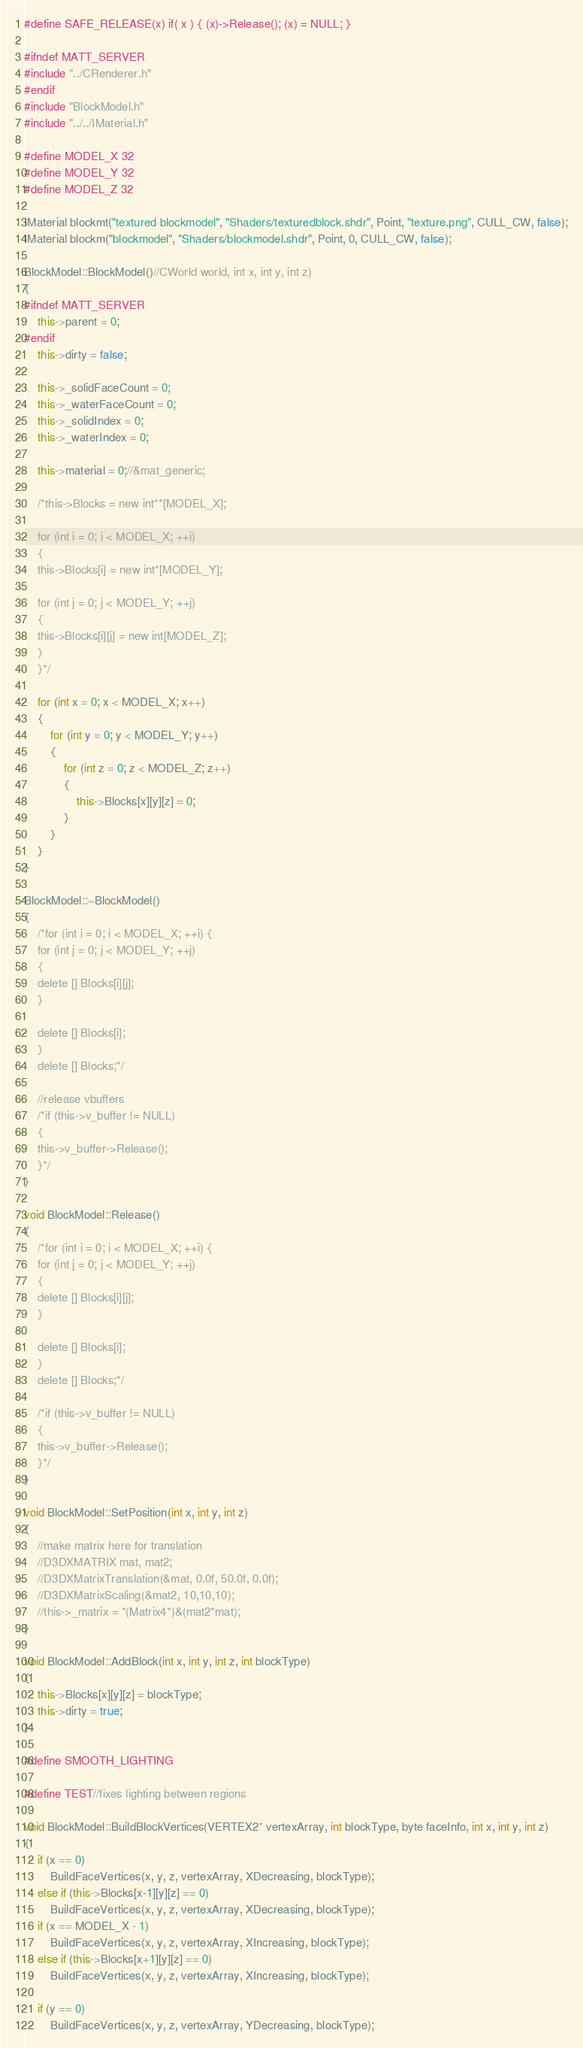<code> <loc_0><loc_0><loc_500><loc_500><_C++_>#define SAFE_RELEASE(x) if( x ) { (x)->Release(); (x) = NULL; }

#ifndef MATT_SERVER
#include "../CRenderer.h"
#endif
#include "BlockModel.h"
#include "../../IMaterial.h"

#define MODEL_X 32
#define MODEL_Y 32
#define MODEL_Z 32

IMaterial blockmt("textured blockmodel", "Shaders/texturedblock.shdr", Point, "texture.png", CULL_CW, false);
IMaterial blockm("blockmodel", "Shaders/blockmodel.shdr", Point, 0, CULL_CW, false);

BlockModel::BlockModel()//CWorld world, int x, int y, int z)
{
#ifndef MATT_SERVER
	this->parent = 0;
#endif
	this->dirty = false;

	this->_solidFaceCount = 0;
	this->_waterFaceCount = 0;
	this->_solidIndex = 0;
	this->_waterIndex = 0;

	this->material = 0;//&mat_generic;

	/*this->Blocks = new int**[MODEL_X];

	for (int i = 0; i < MODEL_X; ++i)
	{
	this->Blocks[i] = new int*[MODEL_Y];

	for (int j = 0; j < MODEL_Y; ++j)
	{
	this->Blocks[i][j] = new int[MODEL_Z];
	}
	}*/

	for (int x = 0; x < MODEL_X; x++)
	{
		for (int y = 0; y < MODEL_Y; y++)
		{
			for (int z = 0; z < MODEL_Z; z++)
			{
				this->Blocks[x][y][z] = 0;
			}
		}
	}
}

BlockModel::~BlockModel()
{
	/*for (int i = 0; i < MODEL_X; ++i) {
	for (int j = 0; j < MODEL_Y; ++j)
	{
	delete [] Blocks[i][j];
	}

	delete [] Blocks[i];
	}
	delete [] Blocks;*/

	//release vbuffers
	/*if (this->v_buffer != NULL)
	{
	this->v_buffer->Release();
	}*/
}

void BlockModel::Release()
{
	/*for (int i = 0; i < MODEL_X; ++i) {
	for (int j = 0; j < MODEL_Y; ++j)
	{
	delete [] Blocks[i][j];
	}

	delete [] Blocks[i];
	}
	delete [] Blocks;*/

	/*if (this->v_buffer != NULL)
	{
	this->v_buffer->Release();
	}*/
}

void BlockModel::SetPosition(int x, int y, int z)
{
	//make matrix here for translation
	//D3DXMATRIX mat, mat2;
	//D3DXMatrixTranslation(&mat, 0.0f, 50.0f, 0.0f);
	//D3DXMatrixScaling(&mat2, 10,10,10);
	//this->_matrix = *(Matrix4*)&(mat2*mat);
}

void BlockModel::AddBlock(int x, int y, int z, int blockType)
{
	this->Blocks[x][y][z] = blockType;
	this->dirty = true;
}

#define SMOOTH_LIGHTING

#define TEST//fixes lighting between regions

void BlockModel::BuildBlockVertices(VERTEX2* vertexArray, int blockType, byte faceInfo, int x, int y, int z)
{
	if (x == 0)
		BuildFaceVertices(x, y, z, vertexArray, XDecreasing, blockType);
	else if (this->Blocks[x-1][y][z] == 0)
		BuildFaceVertices(x, y, z, vertexArray, XDecreasing, blockType);
	if (x == MODEL_X - 1)
		BuildFaceVertices(x, y, z, vertexArray, XIncreasing, blockType);
	else if (this->Blocks[x+1][y][z] == 0)
		BuildFaceVertices(x, y, z, vertexArray, XIncreasing, blockType);

	if (y == 0)
		BuildFaceVertices(x, y, z, vertexArray, YDecreasing, blockType);</code> 